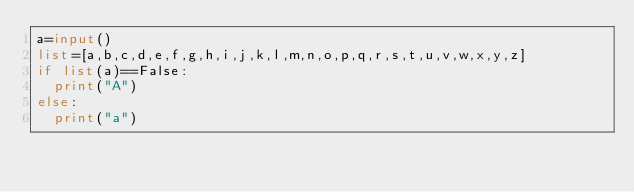<code> <loc_0><loc_0><loc_500><loc_500><_Python_>a=input()
list=[a,b,c,d,e,f,g,h,i,j,k,l,m,n,o,p,q,r,s,t,u,v,w,x,y,z]
if list(a)==False:
  print("A")
else:
  print("a")
</code> 